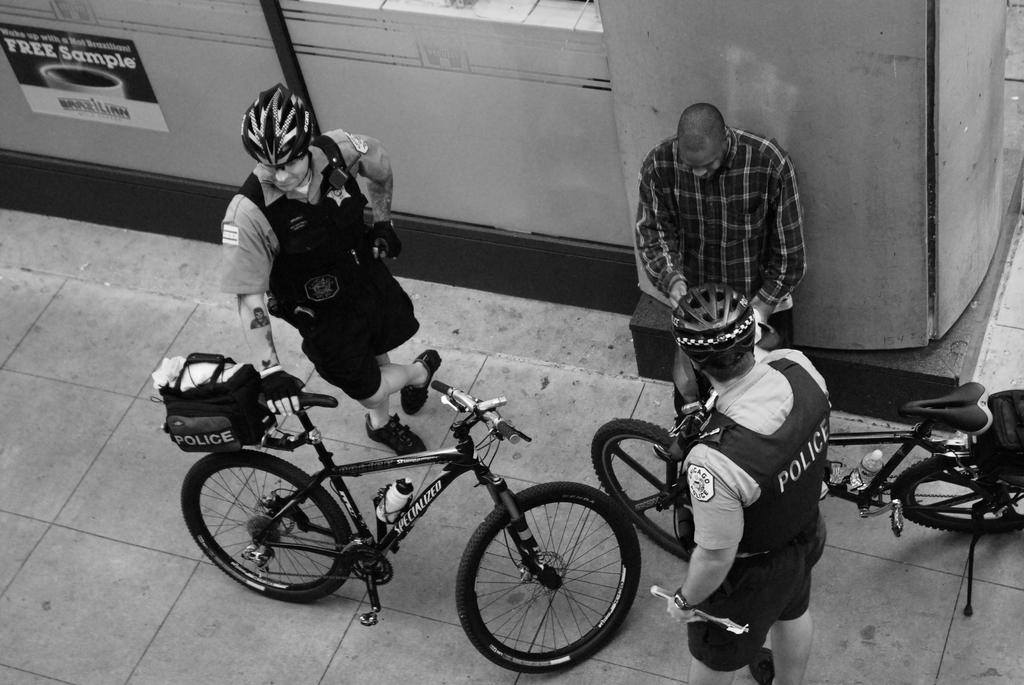How many people are in the foreground of the image? There are three men standing in the foreground of the image. What objects are also present in the foreground of the image? There are two bicycles in the foreground of the image. What can be seen at the top of the image? There is a wall visible at the top of the image. What is the tendency of the form and wing in the image? There is no form or wing present in the image; it features three men and two bicycles in the foreground, and a wall at the top. 